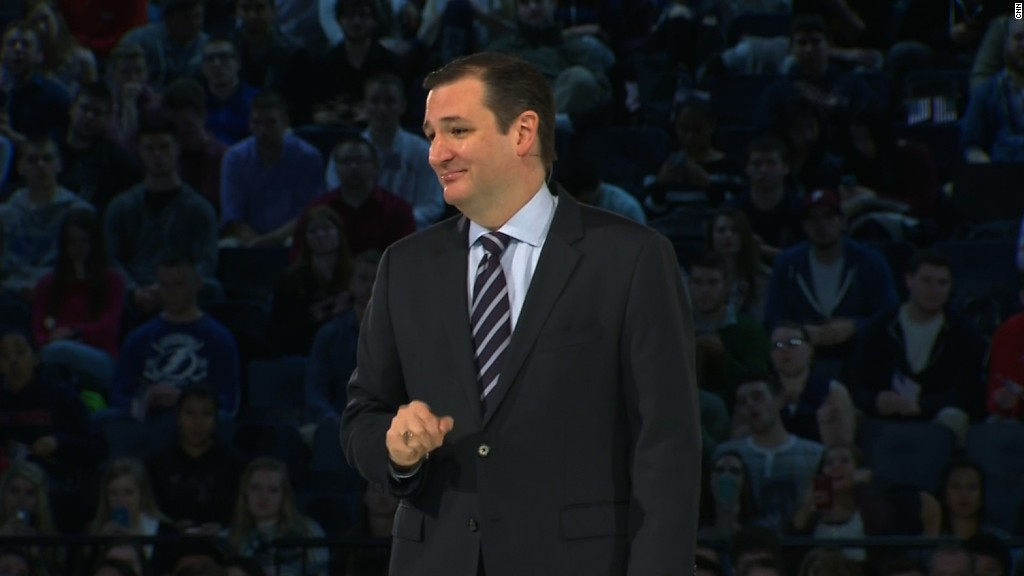Imagine this is a scene from a futuristic university event. How might the event and the interactions differ from today's context? In a futuristic university event, the scene would likely be enhanced by advanced technology. The audience might be wearing augmented reality glasses to receive additional layers of information in real-time, such as notes, data charts, or even translations. The speaker might employ holographic displays to illustrate points in a 3D format, making the presentation more dynamic and interactive. There could be real-time feedback and polls conducted through the audience's devices, creating a more engaged and participative environment. The more advanced seating arrangements could ensure maximum visibility and comfort, possibly with adaptive seating that adjusts to each individual's preferences. 